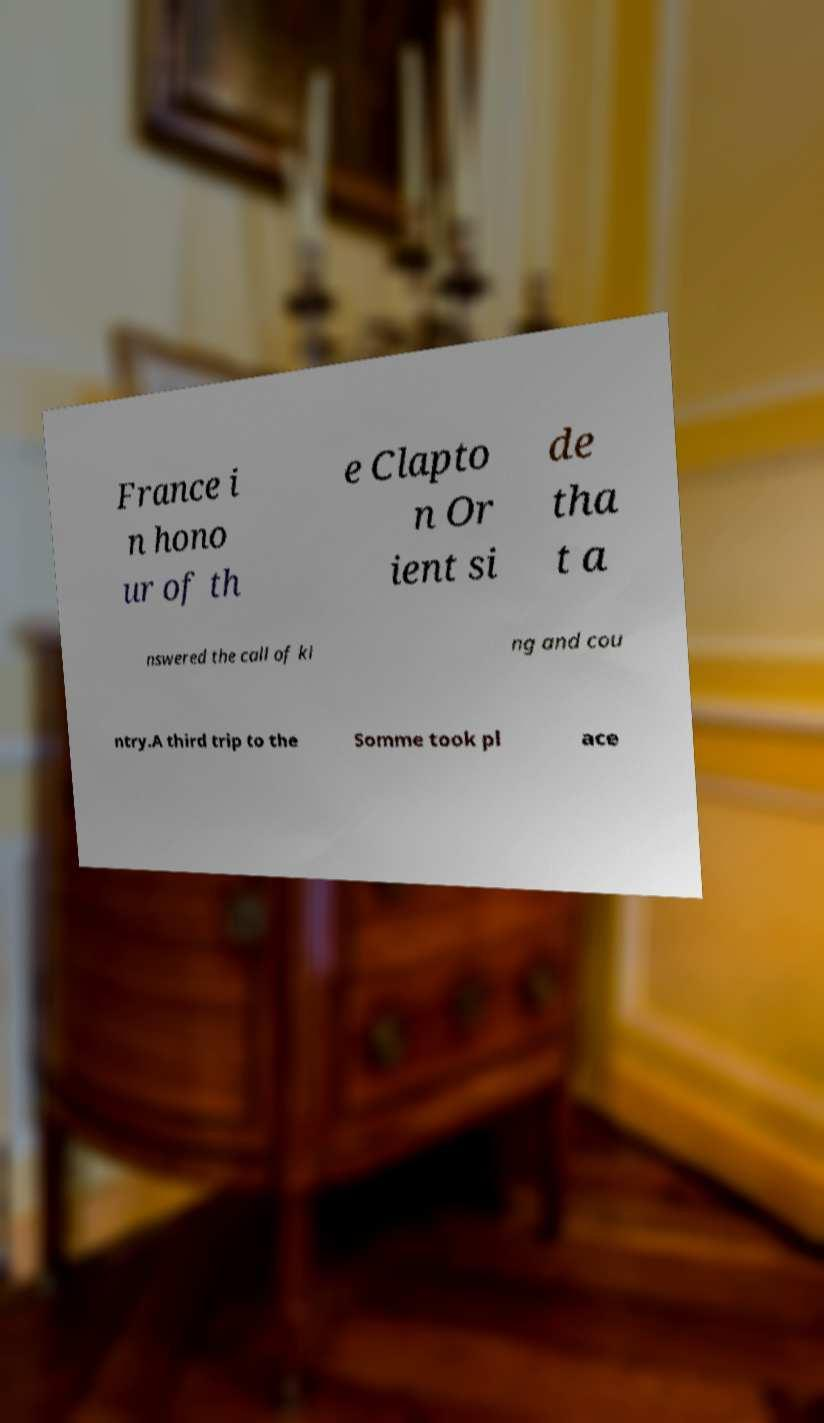Please identify and transcribe the text found in this image. France i n hono ur of th e Clapto n Or ient si de tha t a nswered the call of ki ng and cou ntry.A third trip to the Somme took pl ace 